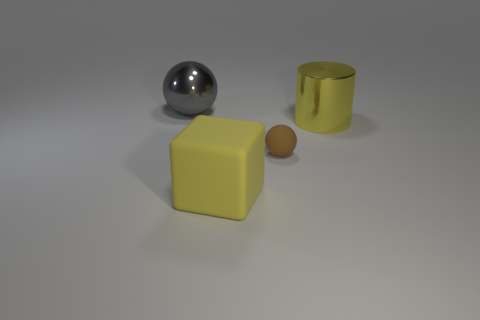Subtract all cyan cylinders. Subtract all brown cubes. How many cylinders are left? 1 Add 2 cyan shiny spheres. How many objects exist? 6 Subtract all cylinders. How many objects are left? 3 Add 4 small purple matte things. How many small purple matte things exist? 4 Subtract 0 purple cylinders. How many objects are left? 4 Subtract all brown spheres. Subtract all yellow cylinders. How many objects are left? 2 Add 4 metallic things. How many metallic things are left? 6 